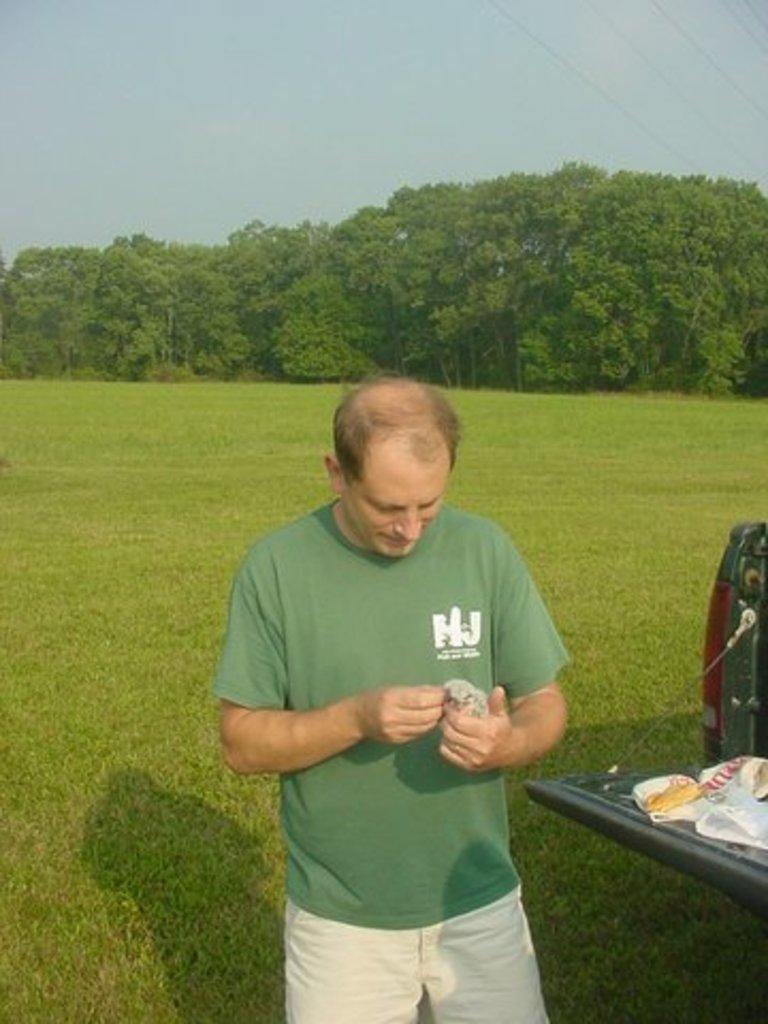Describe this image in one or two sentences. In this image there is the sky towards the top of the image, there are trees, there is grass towards the bottom of the image, there is a man standing towards the bottom of the image, he is holding an object, there is an object towards the right of the image that looks like a vehicle. 